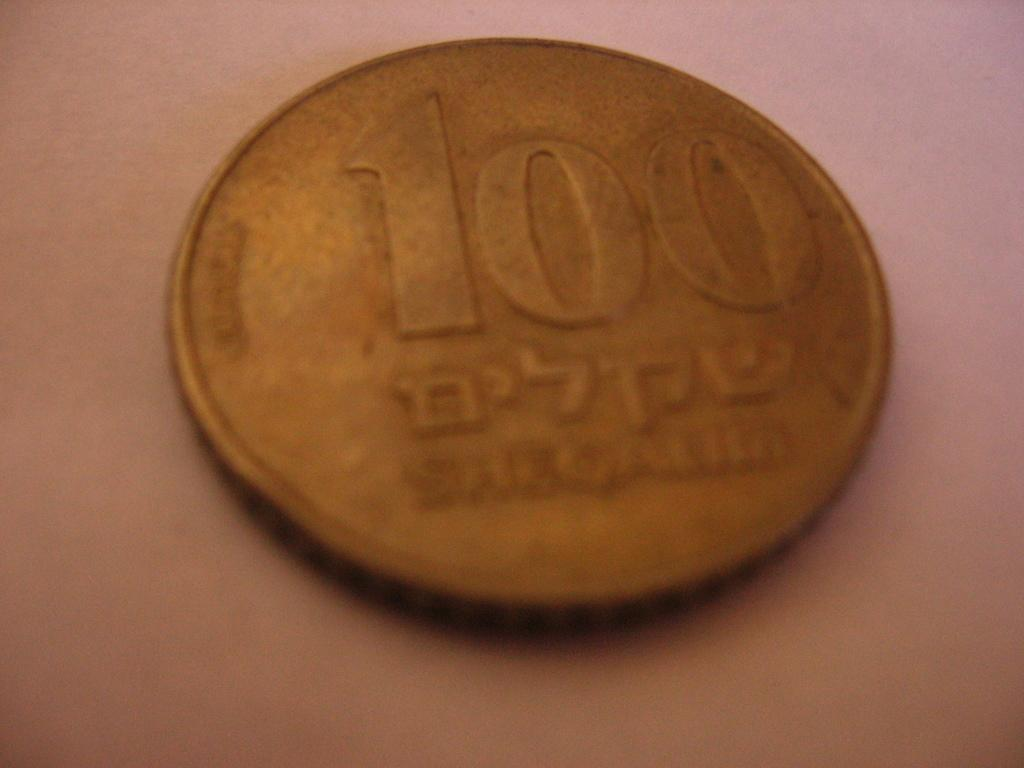What is the color of the surface in the image? The surface in the image is light brown in color. What object can be seen on the surface? There is a coin on the surface. What features are present on the coin? The coin has numbers on it and there is writing on the coin. How many legs can be seen on the partner in the image? There is no partner present in the image, and therefore no legs can be seen. 